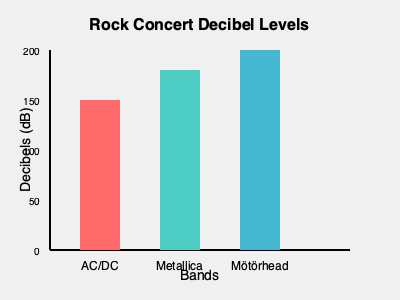As an aspiring rock band member, you're studying the decibel levels of different concerts. The graph shows the maximum decibel levels recorded at concerts for three legendary rock bands. If the difference between the loudest and quietest concert is $x$ dB, and the average decibel level of all three concerts is $y$ dB, what is the value of $x + y$? Let's approach this step-by-step:

1) First, let's identify the decibel levels for each band from the graph:
   AC/DC: 150 dB
   Metallica: 180 dB
   Mötörhead: 200 dB

2) To find $x$, we need to calculate the difference between the loudest and quietest concert:
   $x = 200 - 150 = 50$ dB

3) To find $y$, we need to calculate the average of all three concerts:
   $y = \frac{150 + 180 + 200}{3} = \frac{530}{3} \approx 176.67$ dB

4) Now, we can calculate $x + y$:
   $x + y = 50 + 176.67 = 226.67$

5) Rounding to the nearest whole number (as decibel levels are typically reported as integers):
   $x + y \approx 227$ dB
Answer: 227 dB 